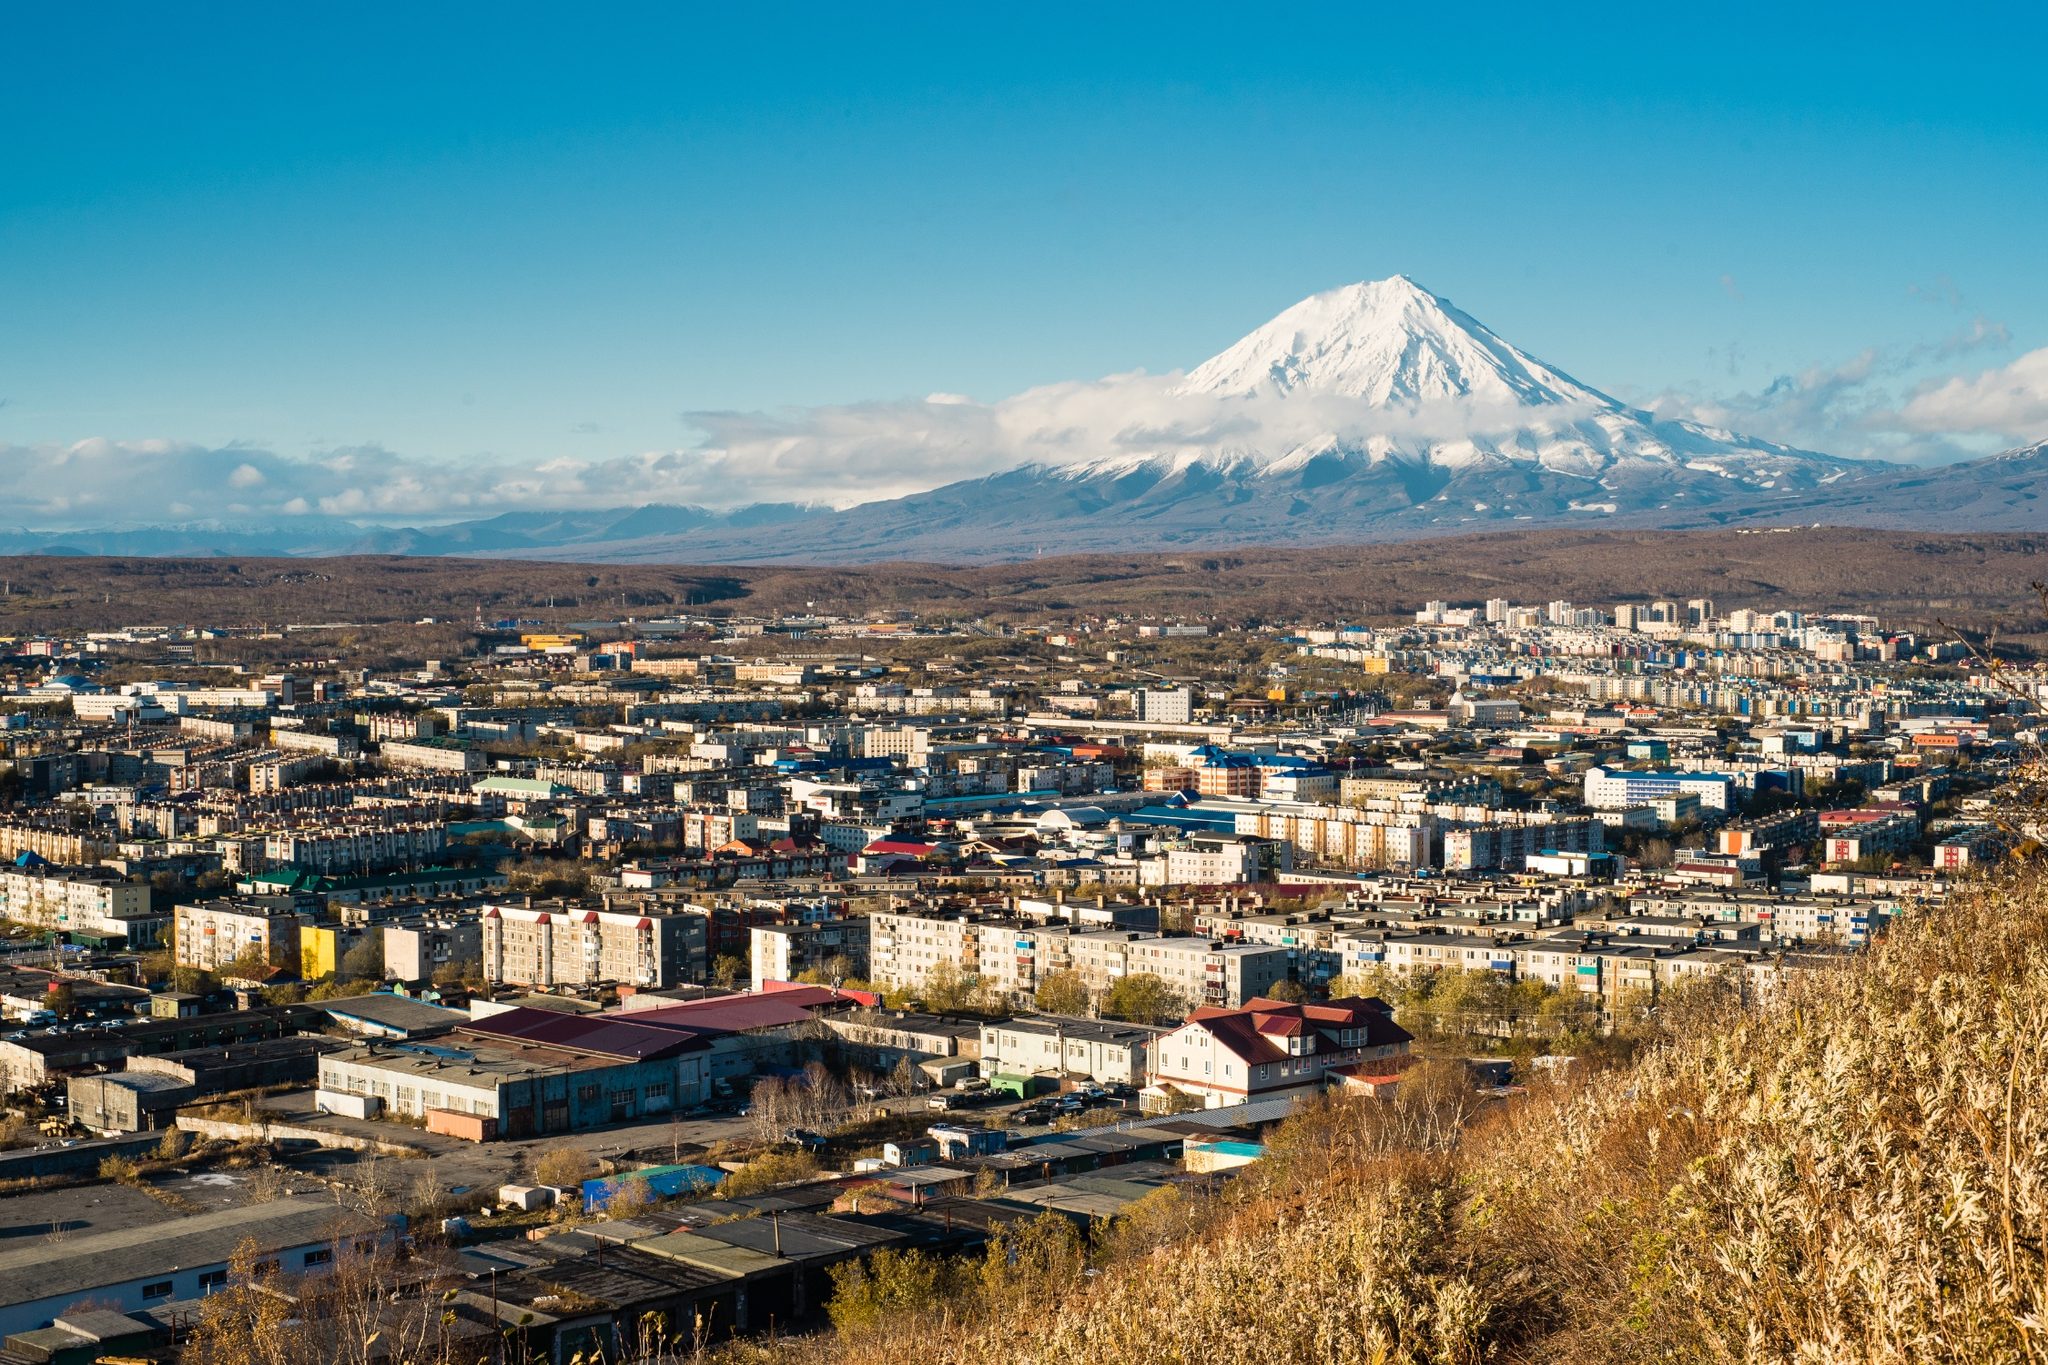Imagine if there were a mythical creature living in the volcano. Describe it in extraordinary detail. Deep within the heart of the Koryaksky volcano, legend speaks of a mythical creature known as 'Pyrosimus'. Pyrosimus is a colossal, dragon-like entity, adorned with scales that shimmer like molten lava and eyes that glow with the inner fires of the earth. Its wings, vast and imposing, are said to span the breadth of the volcano’s peak, their leathery texture rippling with the heat that emanates from its core. Pyrosimus is believed to be a guardian of the land, its deep, resonant growls echoing through the valleys whenever the earth trembles. The creature’s breath can ignite the air, creating a spectacle of flames and light that can be seen for miles. Despite its fearsome appearance, Pyrosimus is considered a protector, ensuring the balance of nature and safeguarding the people living in the shadow of the volcano. During ancient rituals, the inhabitants would offer gifts to the volcano, hoping to appease the mighty Pyrosimus and ensure their safety from natural disasters. 